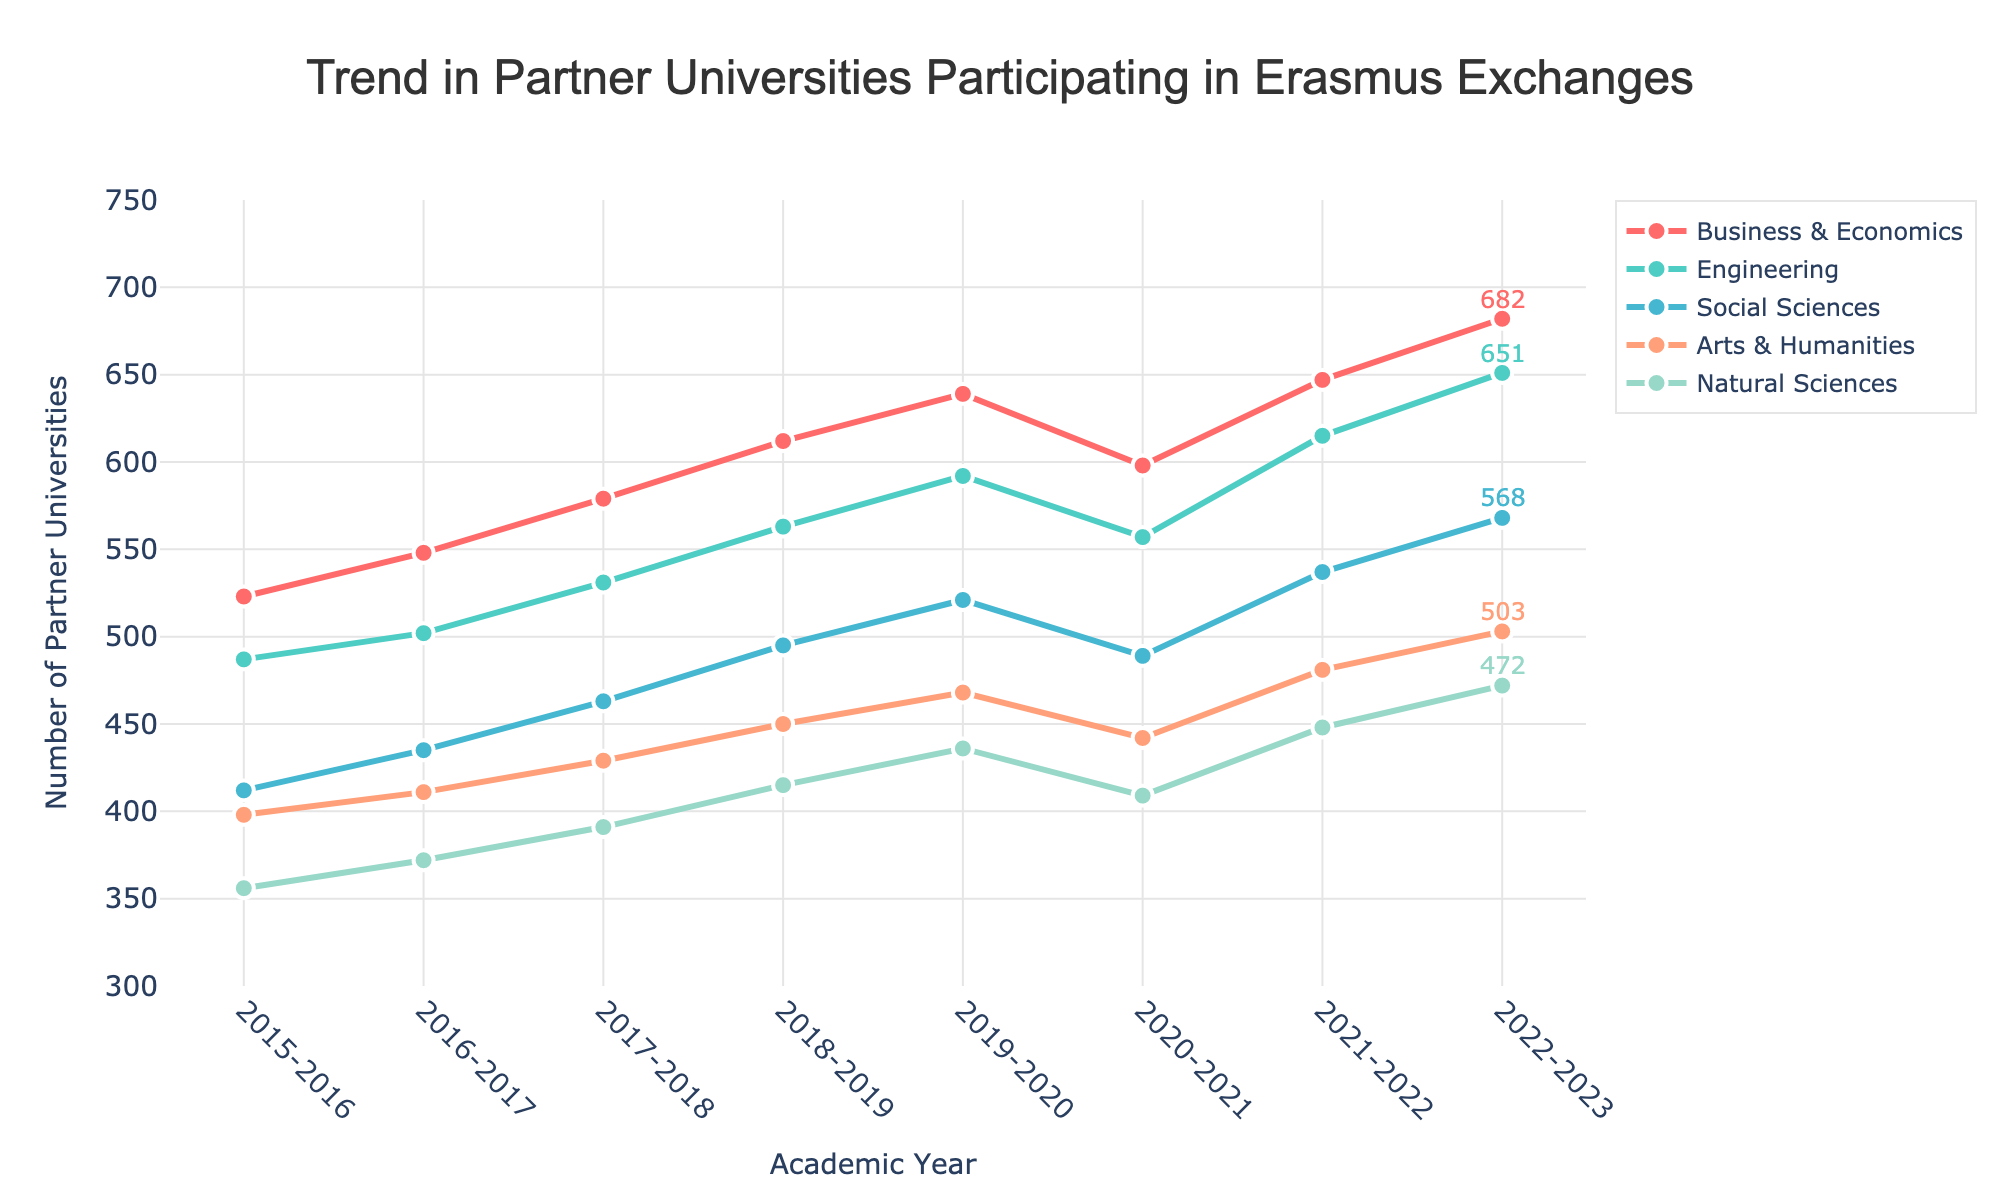What was the overall trend for the number of partner universities in Business & Economics from 2015-2023? The line representing Business & Economics shows a general upward trend from 523 in 2015-2016 to 682 in 2022-2023, indicating a steady increase over the years.
Answer: Upward trend Which academic field had the highest number of partner universities in 2022-2023? By observing the final data points on the graph for the year 2022-2023, the field Business & Economics had the highest number of partner universities, reaching 682.
Answer: Business & Economics In which academic year did the number of partner universities for Engineering first exceed 500? Tracing the Engineering line on the graph, it's seen exceeding 500 for the first time in the 2016-2017 academic year, reaching 502.
Answer: 2016-2017 By how much did the number of partner universities in Social Sciences increase from 2015-2016 to 2022-2023? The number increased from 412 in 2015-2016 to 568 in 2022-2023. The difference is calculated as 568 - 412 = 156.
Answer: 156 Compare the growth rate in partner universities from 2015-2016 to 2022-2023 between Arts & Humanities and Natural Sciences. Which had a higher growth rate? Arts & Humanities grew from 398 to 503, which is an increase of 105 (503 - 398). Natural Sciences grew from 356 to 472, an increase of 116 (472 - 356). Despite Natural Sciences having a larger absolute increase, for growth rate (percentage increase), Arts & Humanities had a higher relative growth rate (105/398 ≈ 26.4%) compared to Natural Sciences (116/356 ≈ 32.6%).
Answer: Natural Sciences Which year showed a decrease in the number of partner universities across all fields, except for Arts & Humanities? The year 2020-2021 showed a decrease in the number of partner universities for Business & Economics, Engineering, Social Sciences, and Natural Sciences, while Arts & Humanities remained relatively stable or slightly decreased.
Answer: 2020-2021 What is the difference in the number of partner universities between Engineering and Natural Sciences in the 2022-2023 academic year? The 2022-2023 data shows Engineering with 651 and Natural Sciences with 472. The difference is calculated as 651 - 472 = 179.
Answer: 179 What is the average number of partner universities for Social Sciences over these eight years? Summing up the numbers for Social Sciences from 2015-2023 (412 + 435 + 463 + 495 + 521 + 489 + 537 + 568) gives a total of 3920. Dividing by 8 gives an average of 3920 / 8 = 490.
Answer: 490 How did the number of partner universities for Business & Economics change from 2019-2020 to 2020-2021? The number decreased from 639 in 2019-2020 to 598 in 2020-2021, a decrease by 639 - 598 = 41.
Answer: Decreased by 41 Which field had the most consistent increase in the number of partner universities over the years? By viewing the slopes of the lines on the graph, Business & Economics consistently shows an upward trend without major fluctuations, indicating the most consistent increase.
Answer: Business & Economics 2021-2022 showed the lowest number of partner universities for which field, and how does this compare to its value in 2022-2023? In 2021-2022, the field Natural Sciences had 448 partner universities, the lowest among the fields. By 2022-2023, it increased to 472, an increase of 472 - 448 = 24.
Answer: Natural Sciences, increased by 24 